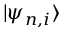<formula> <loc_0><loc_0><loc_500><loc_500>| \psi _ { n , i } \rangle</formula> 